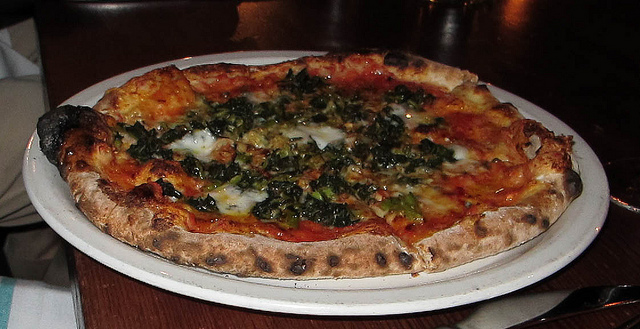<image>What meat is on the pizza? It's ambiguous what meat is on the pizza. It could be sausage, chicken, bacon or none. What meat is on the pizza? I don't know what meat is on the pizza. It can be sausage, chicken, or bacon. 